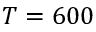<formula> <loc_0><loc_0><loc_500><loc_500>T = 6 0 0</formula> 